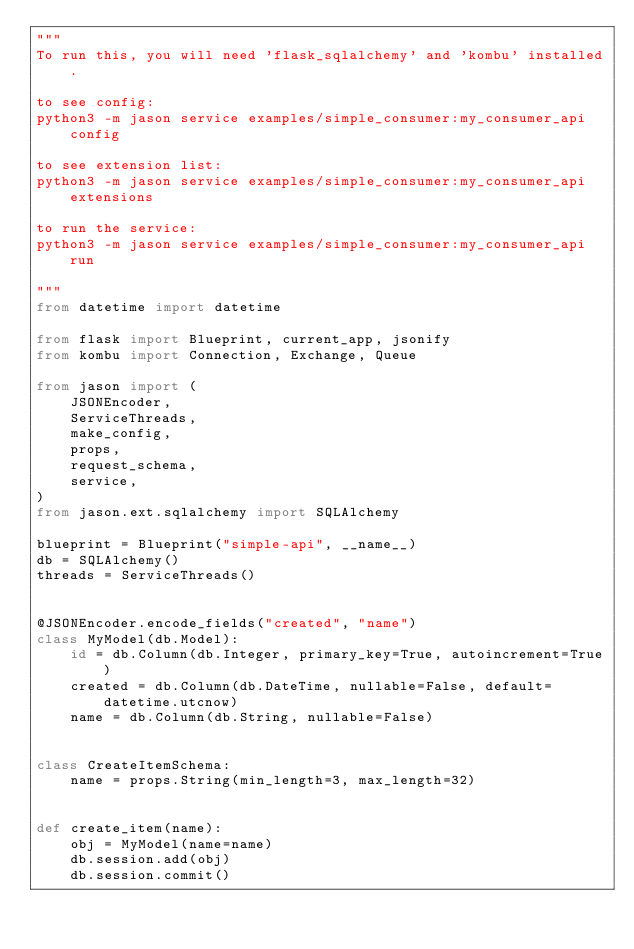Convert code to text. <code><loc_0><loc_0><loc_500><loc_500><_Python_>"""
To run this, you will need 'flask_sqlalchemy' and 'kombu' installed.

to see config:
python3 -m jason service examples/simple_consumer:my_consumer_api config

to see extension list:
python3 -m jason service examples/simple_consumer:my_consumer_api extensions

to run the service:
python3 -m jason service examples/simple_consumer:my_consumer_api run

"""
from datetime import datetime

from flask import Blueprint, current_app, jsonify
from kombu import Connection, Exchange, Queue

from jason import (
    JSONEncoder,
    ServiceThreads,
    make_config,
    props,
    request_schema,
    service,
)
from jason.ext.sqlalchemy import SQLAlchemy

blueprint = Blueprint("simple-api", __name__)
db = SQLAlchemy()
threads = ServiceThreads()


@JSONEncoder.encode_fields("created", "name")
class MyModel(db.Model):
    id = db.Column(db.Integer, primary_key=True, autoincrement=True)
    created = db.Column(db.DateTime, nullable=False, default=datetime.utcnow)
    name = db.Column(db.String, nullable=False)


class CreateItemSchema:
    name = props.String(min_length=3, max_length=32)


def create_item(name):
    obj = MyModel(name=name)
    db.session.add(obj)
    db.session.commit()

</code> 